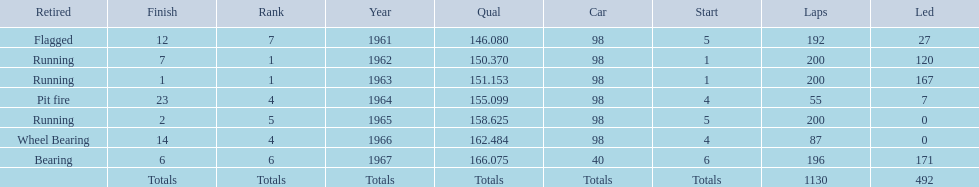How many total laps have been driven in the indy 500? 1130. 